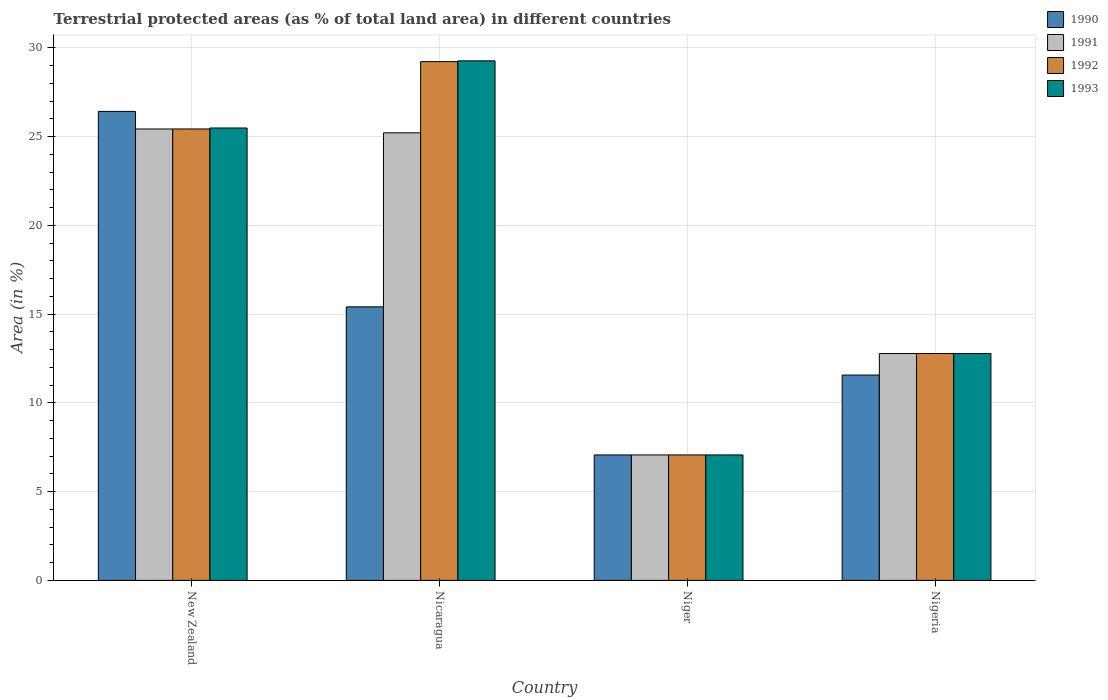Are the number of bars on each tick of the X-axis equal?
Make the answer very short. Yes. How many bars are there on the 3rd tick from the left?
Your response must be concise. 4. How many bars are there on the 1st tick from the right?
Offer a terse response. 4. What is the label of the 3rd group of bars from the left?
Your answer should be very brief. Niger. What is the percentage of terrestrial protected land in 1992 in Nicaragua?
Give a very brief answer. 29.23. Across all countries, what is the maximum percentage of terrestrial protected land in 1991?
Ensure brevity in your answer.  25.44. Across all countries, what is the minimum percentage of terrestrial protected land in 1991?
Offer a terse response. 7.07. In which country was the percentage of terrestrial protected land in 1993 maximum?
Provide a short and direct response. Nicaragua. In which country was the percentage of terrestrial protected land in 1991 minimum?
Keep it short and to the point. Niger. What is the total percentage of terrestrial protected land in 1993 in the graph?
Give a very brief answer. 74.62. What is the difference between the percentage of terrestrial protected land in 1993 in Nicaragua and that in Nigeria?
Offer a very short reply. 16.49. What is the difference between the percentage of terrestrial protected land in 1990 in New Zealand and the percentage of terrestrial protected land in 1991 in Niger?
Provide a succinct answer. 19.36. What is the average percentage of terrestrial protected land in 1993 per country?
Give a very brief answer. 18.65. What is the difference between the percentage of terrestrial protected land of/in 1990 and percentage of terrestrial protected land of/in 1993 in Nicaragua?
Your response must be concise. -13.86. What is the ratio of the percentage of terrestrial protected land in 1990 in New Zealand to that in Nicaragua?
Ensure brevity in your answer.  1.71. Is the percentage of terrestrial protected land in 1990 in Nicaragua less than that in Niger?
Keep it short and to the point. No. What is the difference between the highest and the second highest percentage of terrestrial protected land in 1993?
Offer a very short reply. 12.71. What is the difference between the highest and the lowest percentage of terrestrial protected land in 1991?
Give a very brief answer. 18.37. Is it the case that in every country, the sum of the percentage of terrestrial protected land in 1991 and percentage of terrestrial protected land in 1992 is greater than the sum of percentage of terrestrial protected land in 1993 and percentage of terrestrial protected land in 1990?
Give a very brief answer. No. What does the 3rd bar from the left in New Zealand represents?
Make the answer very short. 1992. What does the 2nd bar from the right in Nicaragua represents?
Make the answer very short. 1992. How many bars are there?
Keep it short and to the point. 16. Are the values on the major ticks of Y-axis written in scientific E-notation?
Make the answer very short. No. Does the graph contain any zero values?
Make the answer very short. No. Does the graph contain grids?
Ensure brevity in your answer.  Yes. How many legend labels are there?
Ensure brevity in your answer.  4. What is the title of the graph?
Provide a succinct answer. Terrestrial protected areas (as % of total land area) in different countries. Does "1992" appear as one of the legend labels in the graph?
Provide a succinct answer. Yes. What is the label or title of the X-axis?
Keep it short and to the point. Country. What is the label or title of the Y-axis?
Offer a terse response. Area (in %). What is the Area (in %) of 1990 in New Zealand?
Offer a very short reply. 26.42. What is the Area (in %) in 1991 in New Zealand?
Your response must be concise. 25.44. What is the Area (in %) in 1992 in New Zealand?
Provide a succinct answer. 25.44. What is the Area (in %) of 1993 in New Zealand?
Provide a succinct answer. 25.49. What is the Area (in %) in 1990 in Nicaragua?
Offer a terse response. 15.41. What is the Area (in %) of 1991 in Nicaragua?
Keep it short and to the point. 25.22. What is the Area (in %) of 1992 in Nicaragua?
Make the answer very short. 29.23. What is the Area (in %) of 1993 in Nicaragua?
Make the answer very short. 29.27. What is the Area (in %) in 1990 in Niger?
Ensure brevity in your answer.  7.07. What is the Area (in %) in 1991 in Niger?
Offer a terse response. 7.07. What is the Area (in %) of 1992 in Niger?
Keep it short and to the point. 7.07. What is the Area (in %) in 1993 in Niger?
Provide a short and direct response. 7.07. What is the Area (in %) in 1990 in Nigeria?
Offer a terse response. 11.57. What is the Area (in %) in 1991 in Nigeria?
Offer a very short reply. 12.78. What is the Area (in %) of 1992 in Nigeria?
Your answer should be compact. 12.78. What is the Area (in %) in 1993 in Nigeria?
Ensure brevity in your answer.  12.78. Across all countries, what is the maximum Area (in %) in 1990?
Your response must be concise. 26.42. Across all countries, what is the maximum Area (in %) of 1991?
Your answer should be compact. 25.44. Across all countries, what is the maximum Area (in %) of 1992?
Your response must be concise. 29.23. Across all countries, what is the maximum Area (in %) of 1993?
Offer a terse response. 29.27. Across all countries, what is the minimum Area (in %) in 1990?
Your response must be concise. 7.07. Across all countries, what is the minimum Area (in %) in 1991?
Make the answer very short. 7.07. Across all countries, what is the minimum Area (in %) of 1992?
Provide a short and direct response. 7.07. Across all countries, what is the minimum Area (in %) in 1993?
Your response must be concise. 7.07. What is the total Area (in %) in 1990 in the graph?
Keep it short and to the point. 60.48. What is the total Area (in %) of 1991 in the graph?
Your answer should be compact. 70.51. What is the total Area (in %) of 1992 in the graph?
Your response must be concise. 74.52. What is the total Area (in %) in 1993 in the graph?
Provide a succinct answer. 74.62. What is the difference between the Area (in %) in 1990 in New Zealand and that in Nicaragua?
Offer a very short reply. 11.01. What is the difference between the Area (in %) in 1991 in New Zealand and that in Nicaragua?
Offer a very short reply. 0.22. What is the difference between the Area (in %) in 1992 in New Zealand and that in Nicaragua?
Your answer should be compact. -3.79. What is the difference between the Area (in %) of 1993 in New Zealand and that in Nicaragua?
Offer a terse response. -3.78. What is the difference between the Area (in %) of 1990 in New Zealand and that in Niger?
Offer a terse response. 19.36. What is the difference between the Area (in %) of 1991 in New Zealand and that in Niger?
Your answer should be compact. 18.37. What is the difference between the Area (in %) of 1992 in New Zealand and that in Niger?
Make the answer very short. 18.37. What is the difference between the Area (in %) in 1993 in New Zealand and that in Niger?
Ensure brevity in your answer.  18.42. What is the difference between the Area (in %) of 1990 in New Zealand and that in Nigeria?
Keep it short and to the point. 14.86. What is the difference between the Area (in %) in 1991 in New Zealand and that in Nigeria?
Offer a terse response. 12.65. What is the difference between the Area (in %) in 1992 in New Zealand and that in Nigeria?
Offer a very short reply. 12.65. What is the difference between the Area (in %) in 1993 in New Zealand and that in Nigeria?
Ensure brevity in your answer.  12.71. What is the difference between the Area (in %) in 1990 in Nicaragua and that in Niger?
Give a very brief answer. 8.34. What is the difference between the Area (in %) in 1991 in Nicaragua and that in Niger?
Your answer should be very brief. 18.15. What is the difference between the Area (in %) in 1992 in Nicaragua and that in Niger?
Provide a short and direct response. 22.16. What is the difference between the Area (in %) of 1993 in Nicaragua and that in Niger?
Give a very brief answer. 22.2. What is the difference between the Area (in %) of 1990 in Nicaragua and that in Nigeria?
Offer a terse response. 3.84. What is the difference between the Area (in %) of 1991 in Nicaragua and that in Nigeria?
Offer a terse response. 12.44. What is the difference between the Area (in %) of 1992 in Nicaragua and that in Nigeria?
Your answer should be compact. 16.45. What is the difference between the Area (in %) in 1993 in Nicaragua and that in Nigeria?
Provide a short and direct response. 16.49. What is the difference between the Area (in %) in 1990 in Niger and that in Nigeria?
Give a very brief answer. -4.5. What is the difference between the Area (in %) of 1991 in Niger and that in Nigeria?
Make the answer very short. -5.71. What is the difference between the Area (in %) of 1992 in Niger and that in Nigeria?
Provide a succinct answer. -5.71. What is the difference between the Area (in %) of 1993 in Niger and that in Nigeria?
Provide a succinct answer. -5.71. What is the difference between the Area (in %) in 1990 in New Zealand and the Area (in %) in 1991 in Nicaragua?
Your answer should be very brief. 1.21. What is the difference between the Area (in %) of 1990 in New Zealand and the Area (in %) of 1992 in Nicaragua?
Keep it short and to the point. -2.81. What is the difference between the Area (in %) of 1990 in New Zealand and the Area (in %) of 1993 in Nicaragua?
Offer a terse response. -2.85. What is the difference between the Area (in %) in 1991 in New Zealand and the Area (in %) in 1992 in Nicaragua?
Offer a terse response. -3.79. What is the difference between the Area (in %) in 1991 in New Zealand and the Area (in %) in 1993 in Nicaragua?
Give a very brief answer. -3.84. What is the difference between the Area (in %) in 1992 in New Zealand and the Area (in %) in 1993 in Nicaragua?
Keep it short and to the point. -3.84. What is the difference between the Area (in %) in 1990 in New Zealand and the Area (in %) in 1991 in Niger?
Offer a very short reply. 19.36. What is the difference between the Area (in %) of 1990 in New Zealand and the Area (in %) of 1992 in Niger?
Offer a terse response. 19.36. What is the difference between the Area (in %) of 1990 in New Zealand and the Area (in %) of 1993 in Niger?
Make the answer very short. 19.36. What is the difference between the Area (in %) of 1991 in New Zealand and the Area (in %) of 1992 in Niger?
Make the answer very short. 18.37. What is the difference between the Area (in %) in 1991 in New Zealand and the Area (in %) in 1993 in Niger?
Your answer should be compact. 18.37. What is the difference between the Area (in %) in 1992 in New Zealand and the Area (in %) in 1993 in Niger?
Give a very brief answer. 18.37. What is the difference between the Area (in %) in 1990 in New Zealand and the Area (in %) in 1991 in Nigeria?
Provide a succinct answer. 13.64. What is the difference between the Area (in %) of 1990 in New Zealand and the Area (in %) of 1992 in Nigeria?
Ensure brevity in your answer.  13.64. What is the difference between the Area (in %) in 1990 in New Zealand and the Area (in %) in 1993 in Nigeria?
Ensure brevity in your answer.  13.64. What is the difference between the Area (in %) in 1991 in New Zealand and the Area (in %) in 1992 in Nigeria?
Provide a succinct answer. 12.65. What is the difference between the Area (in %) in 1991 in New Zealand and the Area (in %) in 1993 in Nigeria?
Your response must be concise. 12.65. What is the difference between the Area (in %) in 1992 in New Zealand and the Area (in %) in 1993 in Nigeria?
Make the answer very short. 12.65. What is the difference between the Area (in %) in 1990 in Nicaragua and the Area (in %) in 1991 in Niger?
Your answer should be very brief. 8.34. What is the difference between the Area (in %) of 1990 in Nicaragua and the Area (in %) of 1992 in Niger?
Your answer should be very brief. 8.34. What is the difference between the Area (in %) of 1990 in Nicaragua and the Area (in %) of 1993 in Niger?
Your response must be concise. 8.34. What is the difference between the Area (in %) in 1991 in Nicaragua and the Area (in %) in 1992 in Niger?
Ensure brevity in your answer.  18.15. What is the difference between the Area (in %) of 1991 in Nicaragua and the Area (in %) of 1993 in Niger?
Provide a succinct answer. 18.15. What is the difference between the Area (in %) of 1992 in Nicaragua and the Area (in %) of 1993 in Niger?
Your answer should be very brief. 22.16. What is the difference between the Area (in %) in 1990 in Nicaragua and the Area (in %) in 1991 in Nigeria?
Provide a short and direct response. 2.63. What is the difference between the Area (in %) of 1990 in Nicaragua and the Area (in %) of 1992 in Nigeria?
Your answer should be very brief. 2.63. What is the difference between the Area (in %) in 1990 in Nicaragua and the Area (in %) in 1993 in Nigeria?
Keep it short and to the point. 2.63. What is the difference between the Area (in %) of 1991 in Nicaragua and the Area (in %) of 1992 in Nigeria?
Give a very brief answer. 12.44. What is the difference between the Area (in %) of 1991 in Nicaragua and the Area (in %) of 1993 in Nigeria?
Your answer should be very brief. 12.44. What is the difference between the Area (in %) in 1992 in Nicaragua and the Area (in %) in 1993 in Nigeria?
Give a very brief answer. 16.45. What is the difference between the Area (in %) in 1990 in Niger and the Area (in %) in 1991 in Nigeria?
Ensure brevity in your answer.  -5.71. What is the difference between the Area (in %) of 1990 in Niger and the Area (in %) of 1992 in Nigeria?
Ensure brevity in your answer.  -5.71. What is the difference between the Area (in %) of 1990 in Niger and the Area (in %) of 1993 in Nigeria?
Make the answer very short. -5.71. What is the difference between the Area (in %) of 1991 in Niger and the Area (in %) of 1992 in Nigeria?
Give a very brief answer. -5.71. What is the difference between the Area (in %) in 1991 in Niger and the Area (in %) in 1993 in Nigeria?
Provide a succinct answer. -5.71. What is the difference between the Area (in %) in 1992 in Niger and the Area (in %) in 1993 in Nigeria?
Provide a succinct answer. -5.71. What is the average Area (in %) of 1990 per country?
Offer a terse response. 15.12. What is the average Area (in %) in 1991 per country?
Provide a short and direct response. 17.63. What is the average Area (in %) of 1992 per country?
Offer a very short reply. 18.63. What is the average Area (in %) in 1993 per country?
Your response must be concise. 18.65. What is the difference between the Area (in %) of 1990 and Area (in %) of 1993 in New Zealand?
Your answer should be compact. 0.93. What is the difference between the Area (in %) of 1991 and Area (in %) of 1992 in New Zealand?
Offer a very short reply. -0. What is the difference between the Area (in %) of 1991 and Area (in %) of 1993 in New Zealand?
Your answer should be compact. -0.06. What is the difference between the Area (in %) of 1992 and Area (in %) of 1993 in New Zealand?
Give a very brief answer. -0.06. What is the difference between the Area (in %) in 1990 and Area (in %) in 1991 in Nicaragua?
Provide a short and direct response. -9.81. What is the difference between the Area (in %) of 1990 and Area (in %) of 1992 in Nicaragua?
Keep it short and to the point. -13.82. What is the difference between the Area (in %) in 1990 and Area (in %) in 1993 in Nicaragua?
Provide a short and direct response. -13.86. What is the difference between the Area (in %) in 1991 and Area (in %) in 1992 in Nicaragua?
Your answer should be compact. -4.01. What is the difference between the Area (in %) in 1991 and Area (in %) in 1993 in Nicaragua?
Offer a terse response. -4.06. What is the difference between the Area (in %) in 1992 and Area (in %) in 1993 in Nicaragua?
Ensure brevity in your answer.  -0.04. What is the difference between the Area (in %) of 1990 and Area (in %) of 1992 in Niger?
Provide a short and direct response. 0. What is the difference between the Area (in %) in 1990 and Area (in %) in 1993 in Niger?
Keep it short and to the point. 0. What is the difference between the Area (in %) in 1990 and Area (in %) in 1991 in Nigeria?
Offer a very short reply. -1.21. What is the difference between the Area (in %) of 1990 and Area (in %) of 1992 in Nigeria?
Your answer should be compact. -1.21. What is the difference between the Area (in %) in 1990 and Area (in %) in 1993 in Nigeria?
Give a very brief answer. -1.21. What is the difference between the Area (in %) of 1991 and Area (in %) of 1993 in Nigeria?
Your answer should be very brief. 0. What is the difference between the Area (in %) of 1992 and Area (in %) of 1993 in Nigeria?
Offer a terse response. 0. What is the ratio of the Area (in %) of 1990 in New Zealand to that in Nicaragua?
Your answer should be very brief. 1.71. What is the ratio of the Area (in %) of 1991 in New Zealand to that in Nicaragua?
Keep it short and to the point. 1.01. What is the ratio of the Area (in %) of 1992 in New Zealand to that in Nicaragua?
Your answer should be very brief. 0.87. What is the ratio of the Area (in %) in 1993 in New Zealand to that in Nicaragua?
Your answer should be very brief. 0.87. What is the ratio of the Area (in %) of 1990 in New Zealand to that in Niger?
Provide a short and direct response. 3.74. What is the ratio of the Area (in %) in 1991 in New Zealand to that in Niger?
Make the answer very short. 3.6. What is the ratio of the Area (in %) in 1992 in New Zealand to that in Niger?
Offer a terse response. 3.6. What is the ratio of the Area (in %) in 1993 in New Zealand to that in Niger?
Offer a very short reply. 3.61. What is the ratio of the Area (in %) of 1990 in New Zealand to that in Nigeria?
Offer a very short reply. 2.28. What is the ratio of the Area (in %) in 1991 in New Zealand to that in Nigeria?
Your answer should be very brief. 1.99. What is the ratio of the Area (in %) in 1992 in New Zealand to that in Nigeria?
Give a very brief answer. 1.99. What is the ratio of the Area (in %) in 1993 in New Zealand to that in Nigeria?
Offer a very short reply. 1.99. What is the ratio of the Area (in %) in 1990 in Nicaragua to that in Niger?
Make the answer very short. 2.18. What is the ratio of the Area (in %) in 1991 in Nicaragua to that in Niger?
Offer a very short reply. 3.57. What is the ratio of the Area (in %) of 1992 in Nicaragua to that in Niger?
Ensure brevity in your answer.  4.13. What is the ratio of the Area (in %) of 1993 in Nicaragua to that in Niger?
Provide a succinct answer. 4.14. What is the ratio of the Area (in %) in 1990 in Nicaragua to that in Nigeria?
Offer a terse response. 1.33. What is the ratio of the Area (in %) in 1991 in Nicaragua to that in Nigeria?
Your response must be concise. 1.97. What is the ratio of the Area (in %) in 1992 in Nicaragua to that in Nigeria?
Offer a terse response. 2.29. What is the ratio of the Area (in %) of 1993 in Nicaragua to that in Nigeria?
Make the answer very short. 2.29. What is the ratio of the Area (in %) of 1990 in Niger to that in Nigeria?
Your answer should be very brief. 0.61. What is the ratio of the Area (in %) in 1991 in Niger to that in Nigeria?
Your answer should be very brief. 0.55. What is the ratio of the Area (in %) of 1992 in Niger to that in Nigeria?
Make the answer very short. 0.55. What is the ratio of the Area (in %) in 1993 in Niger to that in Nigeria?
Your answer should be very brief. 0.55. What is the difference between the highest and the second highest Area (in %) of 1990?
Keep it short and to the point. 11.01. What is the difference between the highest and the second highest Area (in %) of 1991?
Offer a terse response. 0.22. What is the difference between the highest and the second highest Area (in %) of 1992?
Your answer should be very brief. 3.79. What is the difference between the highest and the second highest Area (in %) in 1993?
Provide a short and direct response. 3.78. What is the difference between the highest and the lowest Area (in %) of 1990?
Your answer should be very brief. 19.36. What is the difference between the highest and the lowest Area (in %) in 1991?
Your response must be concise. 18.37. What is the difference between the highest and the lowest Area (in %) in 1992?
Offer a terse response. 22.16. What is the difference between the highest and the lowest Area (in %) in 1993?
Your response must be concise. 22.2. 